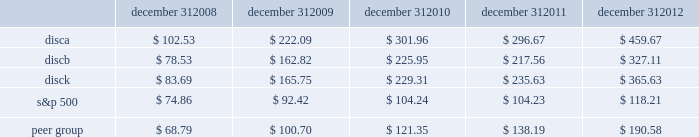Stock performance graph the following graph sets forth the cumulative total shareholder return on our series a common stock , series b common stock and series c common stock as compared with the cumulative total return of the companies listed in the standard and poor 2019s 500 stock index ( 201cs&p 500 index 201d ) and a peer group of companies comprised of cbs corporation class b common stock , news corporation class a common stock , scripps network interactive , inc. , time warner , inc. , viacom , inc .
Class b common stock and the walt disney company .
The graph assumes $ 100 originally invested on september 18 , 2008 , the date upon which our common stock began trading , in each of our series a common stock , series b common stock and series c common stock , the s&p 500 index , and the stock of our peer group companies , including reinvestment of dividends , for the period september 18 , 2008 through december 31 , 2008 and the years ended december 31 , 2009 , 2010 , 2011 , and 2012 .
December 31 , december 31 , december 31 , december 31 , december 31 .
Equity compensation plan information information regarding securities authorized for issuance under equity compensation plans will be set forth in our definitive proxy statement for our 2013 annual meeting of stockholders under the caption 201csecurities authorized for issuance under equity compensation plans , 201d which is incorporated herein by reference. .
What was the 5 year average total return for the a and c series of stock?\\n\\n\\n? 
Computations: ((327.11 + 365.63) / 2)
Answer: 346.37. Stock performance graph the following graph sets forth the cumulative total shareholder return on our series a common stock , series b common stock and series c common stock as compared with the cumulative total return of the companies listed in the standard and poor 2019s 500 stock index ( 201cs&p 500 index 201d ) and a peer group of companies comprised of cbs corporation class b common stock , news corporation class a common stock , scripps network interactive , inc. , time warner , inc. , viacom , inc .
Class b common stock and the walt disney company .
The graph assumes $ 100 originally invested on september 18 , 2008 , the date upon which our common stock began trading , in each of our series a common stock , series b common stock and series c common stock , the s&p 500 index , and the stock of our peer group companies , including reinvestment of dividends , for the period september 18 , 2008 through december 31 , 2008 and the years ended december 31 , 2009 , 2010 , 2011 , and 2012 .
December 31 , december 31 , december 31 , december 31 , december 31 .
Equity compensation plan information information regarding securities authorized for issuance under equity compensation plans will be set forth in our definitive proxy statement for our 2013 annual meeting of stockholders under the caption 201csecurities authorized for issuance under equity compensation plans , 201d which is incorporated herein by reference. .
What was the percentage cumulative total shareholder return on disca common stock from september 18 , 2008 to december 31 , 2012? 
Computations: ((459.67 - 100) / 100)
Answer: 3.5967. 